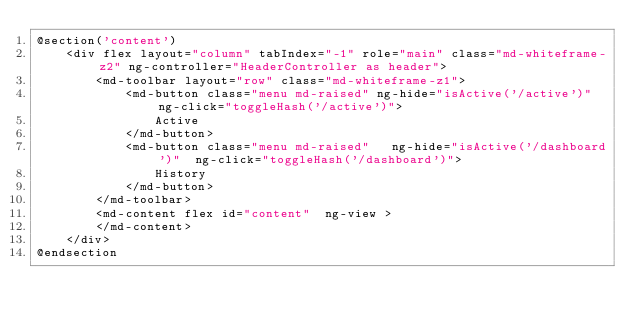Convert code to text. <code><loc_0><loc_0><loc_500><loc_500><_PHP_>@section('content')
    <div flex layout="column" tabIndex="-1" role="main" class="md-whiteframe-z2" ng-controller="HeaderController as header">
        <md-toolbar layout="row" class="md-whiteframe-z1">
            <md-button class="menu md-raised" ng-hide="isActive('/active')"  ng-click="toggleHash('/active')">
                Active
            </md-button>
            <md-button class="menu md-raised"   ng-hide="isActive('/dashboard')"  ng-click="toggleHash('/dashboard')">
                History
            </md-button>
        </md-toolbar>
        <md-content flex id="content"  ng-view >
        </md-content>
    </div>
@endsection
</code> 